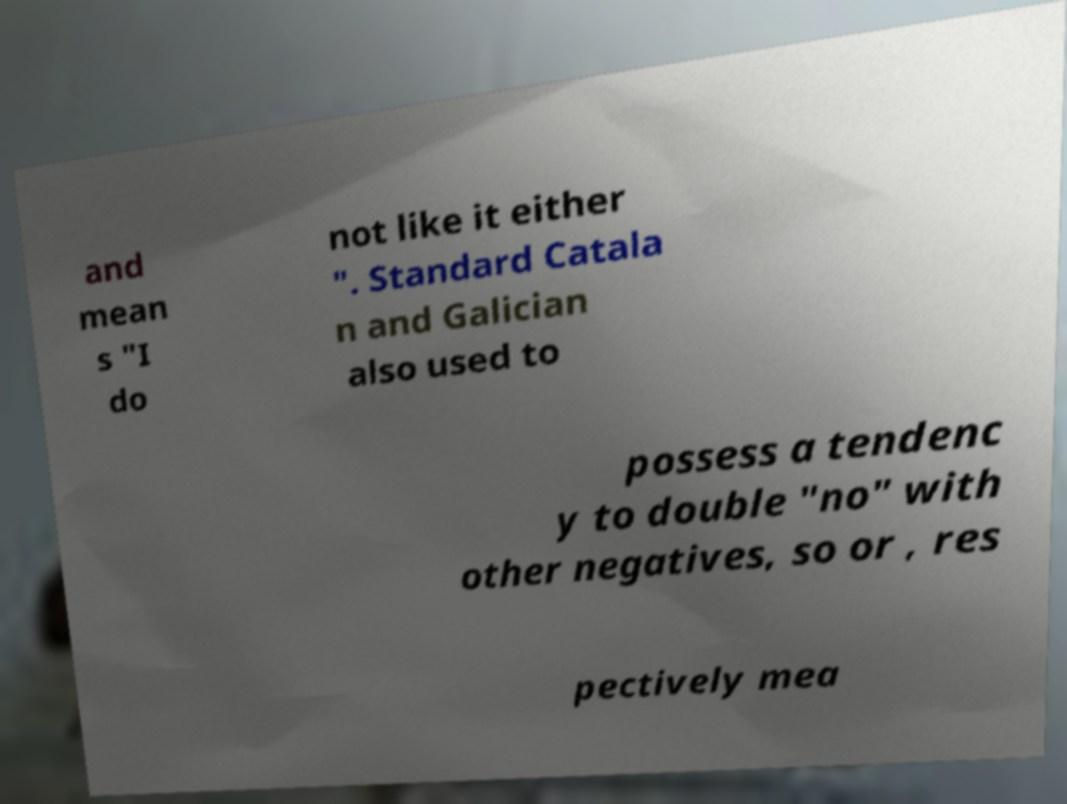Please identify and transcribe the text found in this image. and mean s "I do not like it either ". Standard Catala n and Galician also used to possess a tendenc y to double "no" with other negatives, so or , res pectively mea 